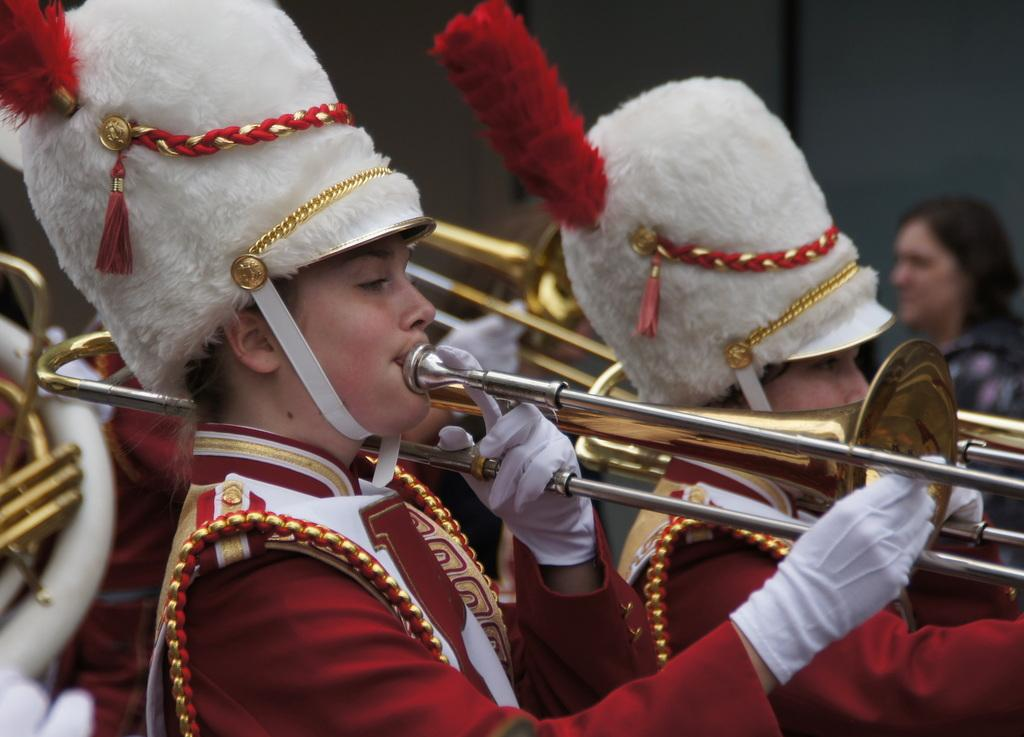How many people are in the image? There are people in the image. What are the people wearing? The people are dressed in a specific manner. What are the people holding in the image? The people are holding musical instruments. Can you describe the background of the image? There is a blurred background in the image, and a wall is visible in the background. Are there any other people in the background? Yes, there is a person in the background. What type of mailbox can be seen in the image? There is no mailbox present in the image. What color is the curtain hanging in the background of the image? There is no curtain visible in the image; only a wall is present in the background. 